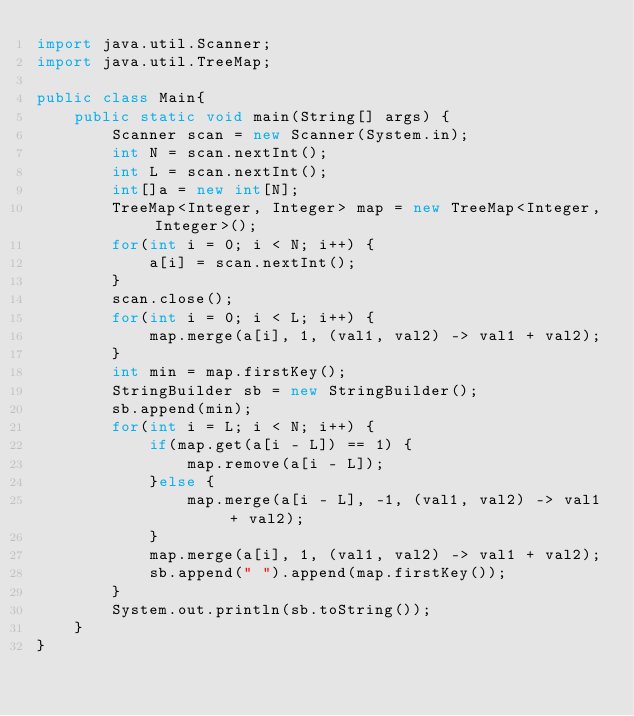<code> <loc_0><loc_0><loc_500><loc_500><_Java_>import java.util.Scanner;
import java.util.TreeMap;

public class Main{
	public static void main(String[] args) {
		Scanner scan = new Scanner(System.in);
		int N = scan.nextInt();
		int L = scan.nextInt();
		int[]a = new int[N];
		TreeMap<Integer, Integer> map = new TreeMap<Integer, Integer>();
		for(int i = 0; i < N; i++) {
			a[i] = scan.nextInt();
		}
		scan.close();
		for(int i = 0; i < L; i++) {
			map.merge(a[i], 1, (val1, val2) -> val1 + val2);
		}
		int min = map.firstKey();
		StringBuilder sb = new StringBuilder();
		sb.append(min);
		for(int i = L; i < N; i++) {
			if(map.get(a[i - L]) == 1) {
				map.remove(a[i - L]);
			}else {
				map.merge(a[i - L], -1, (val1, val2) -> val1 + val2);
			}
			map.merge(a[i], 1, (val1, val2) -> val1 + val2);
			sb.append(" ").append(map.firstKey());
		}
		System.out.println(sb.toString());
	}
}
</code> 